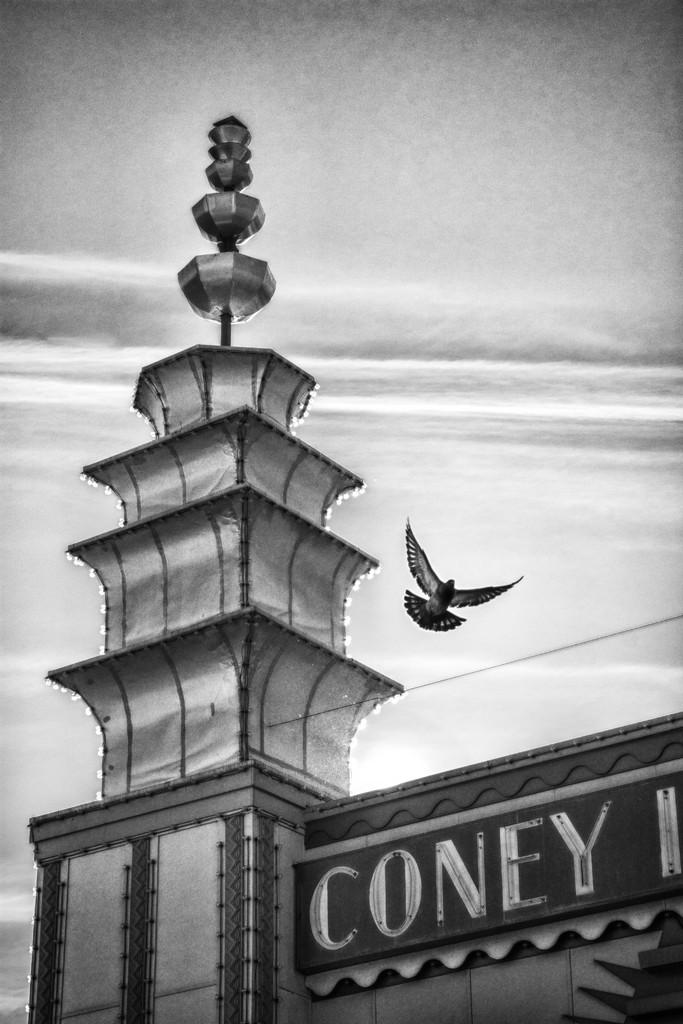What structure can be seen at the bottom of the image? There is an arch at the bottom of the image. What is happening in the sky in the image? A bird is flying in the sky in the image. What color scheme is used in the image? The image is in black and white color. Can you see any teeth on the bird in the image? There are no teeth visible on the bird in the image, as birds do not have teeth. What type of cork is being used to hold the bird in the image? There is no cork present in the image; it features a bird flying in the sky. 